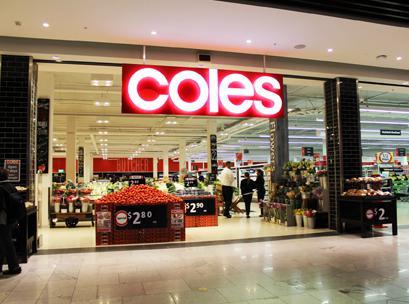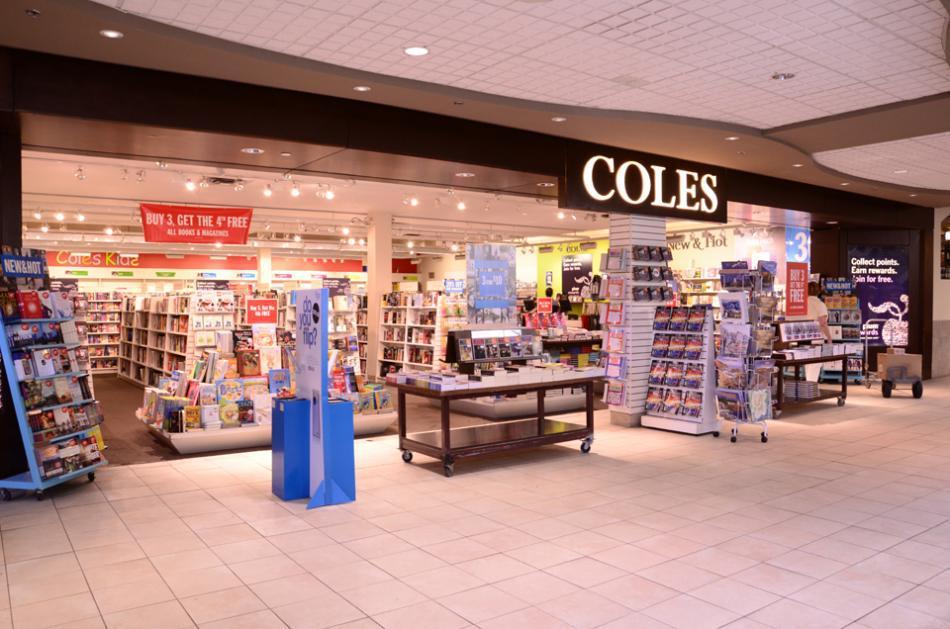The first image is the image on the left, the second image is the image on the right. Assess this claim about the two images: "At least one person is standing near the entrance of the store in the image on the left.". Correct or not? Answer yes or no. Yes. The first image is the image on the left, the second image is the image on the right. Considering the images on both sides, is "An upright blue display stands outside the entry area of one of the stores." valid? Answer yes or no. Yes. 